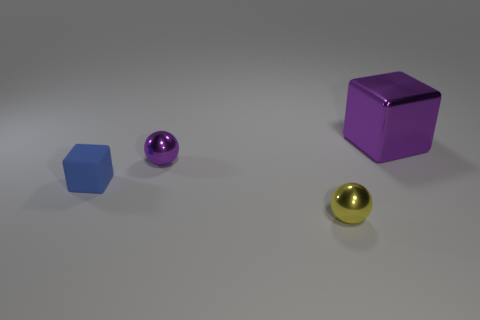Add 3 yellow spheres. How many objects exist? 7 Add 4 big purple blocks. How many big purple blocks are left? 5 Add 1 matte blocks. How many matte blocks exist? 2 Subtract 0 green cubes. How many objects are left? 4 Subtract all large purple blocks. Subtract all matte things. How many objects are left? 2 